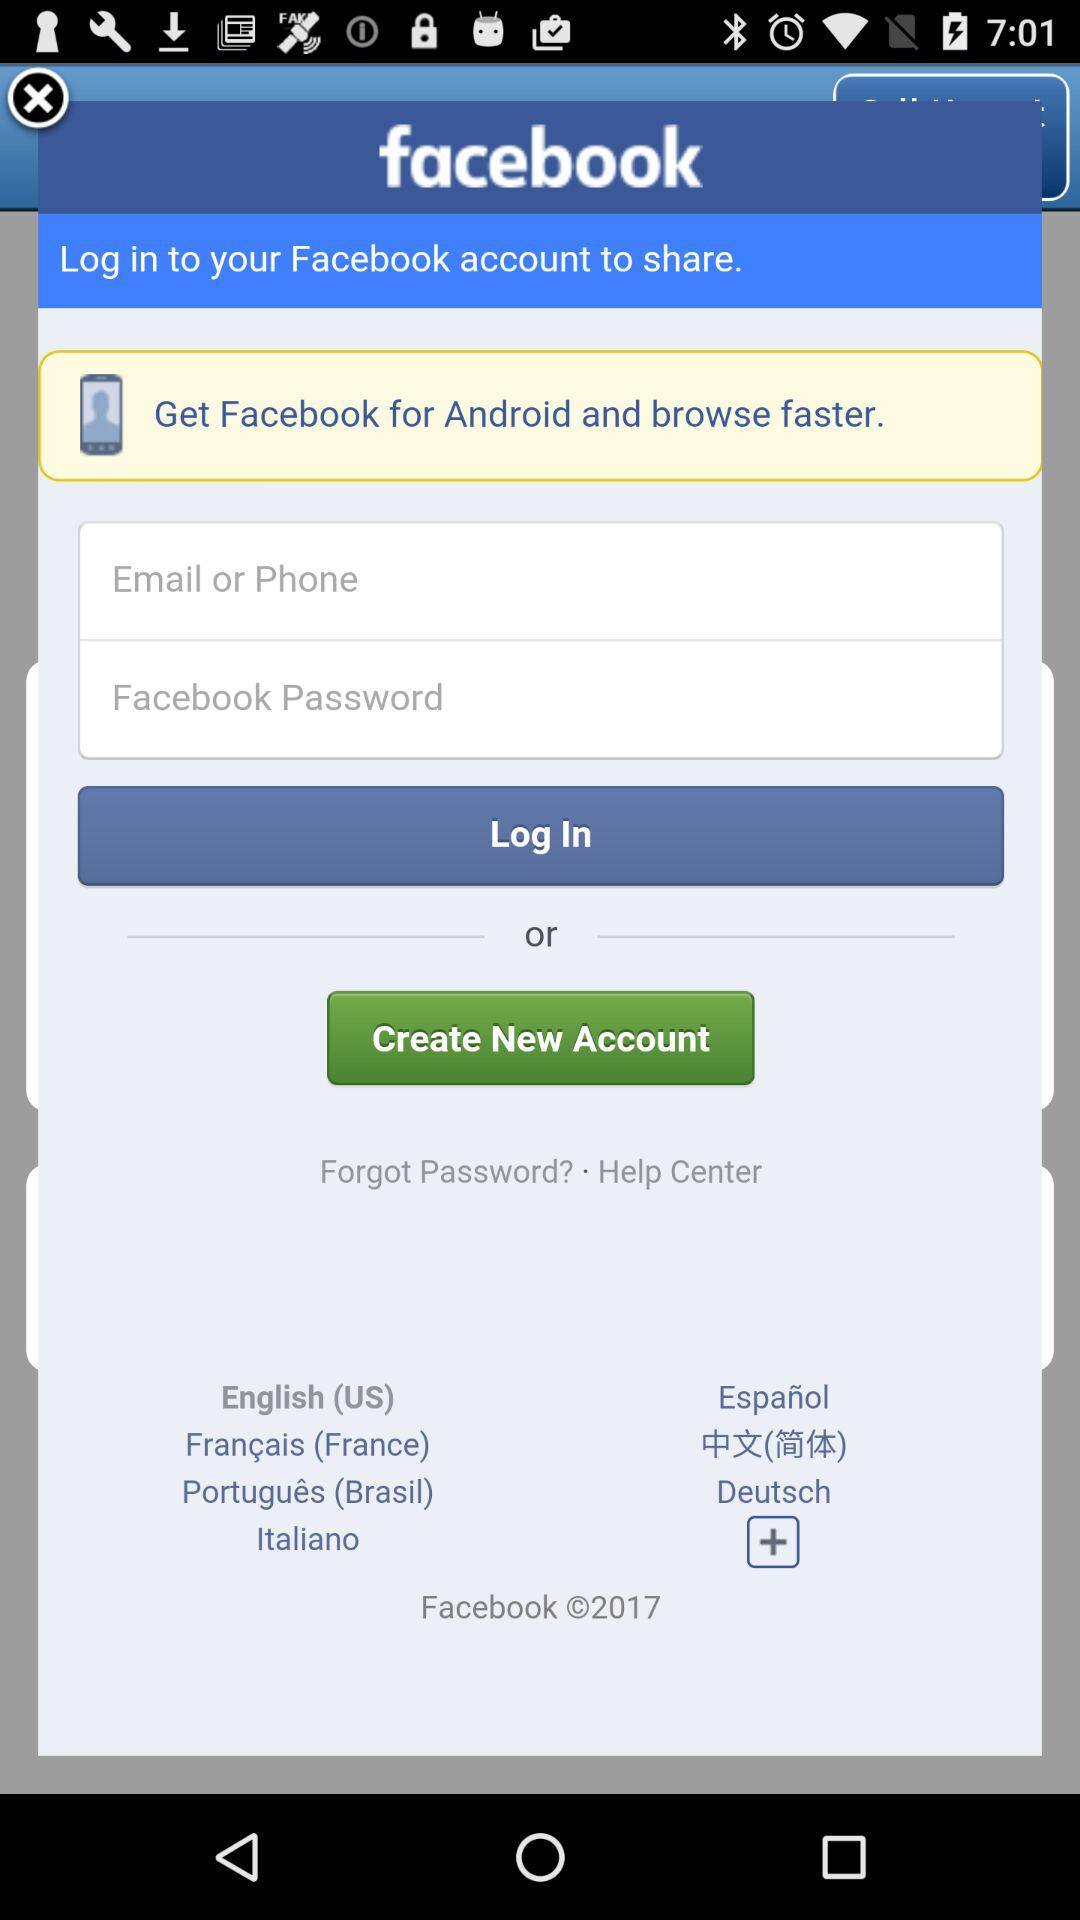What is the app name? The app name is "facebook". 